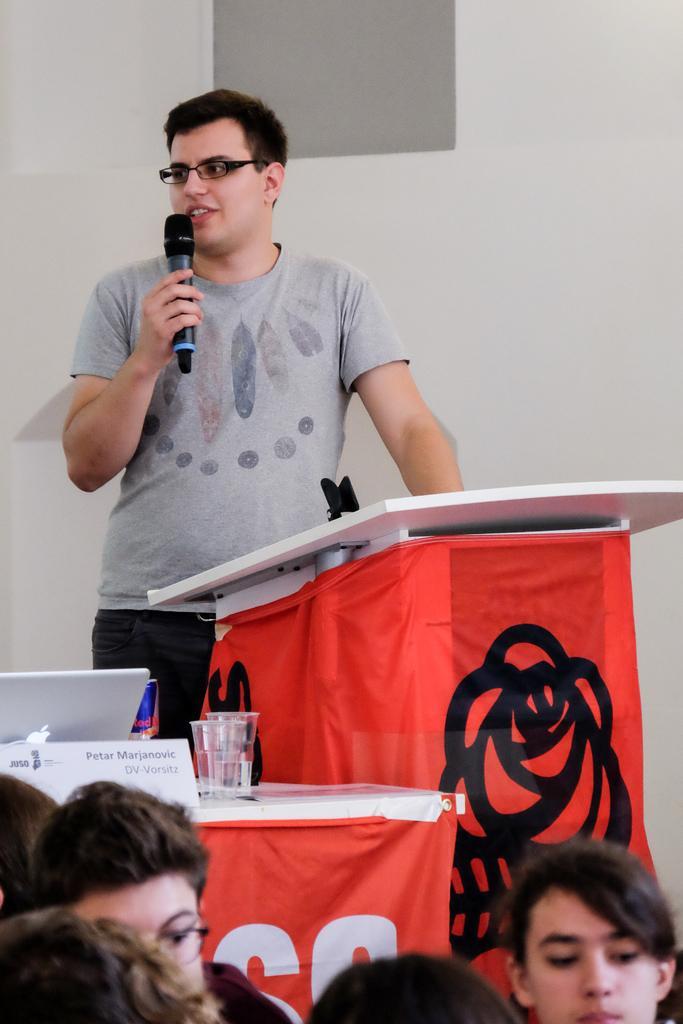Could you give a brief overview of what you see in this image? In this image there is a person holding a mic, in front of him there is a table, beside that table there is another table with glasses, laptop, name plate with some text on it, in front of the table there are a few people. In the background there is a wall. 